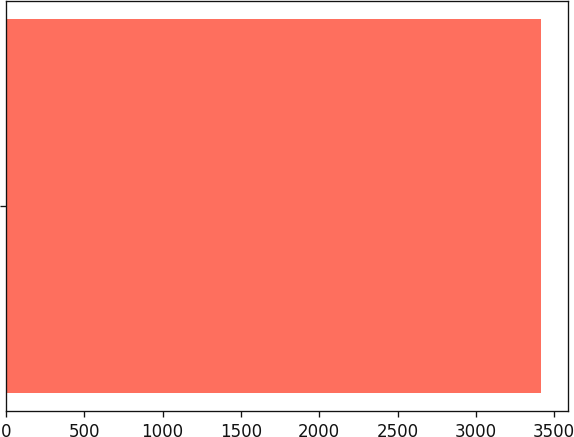<chart> <loc_0><loc_0><loc_500><loc_500><bar_chart><ecel><nl><fcel>3419<nl></chart> 